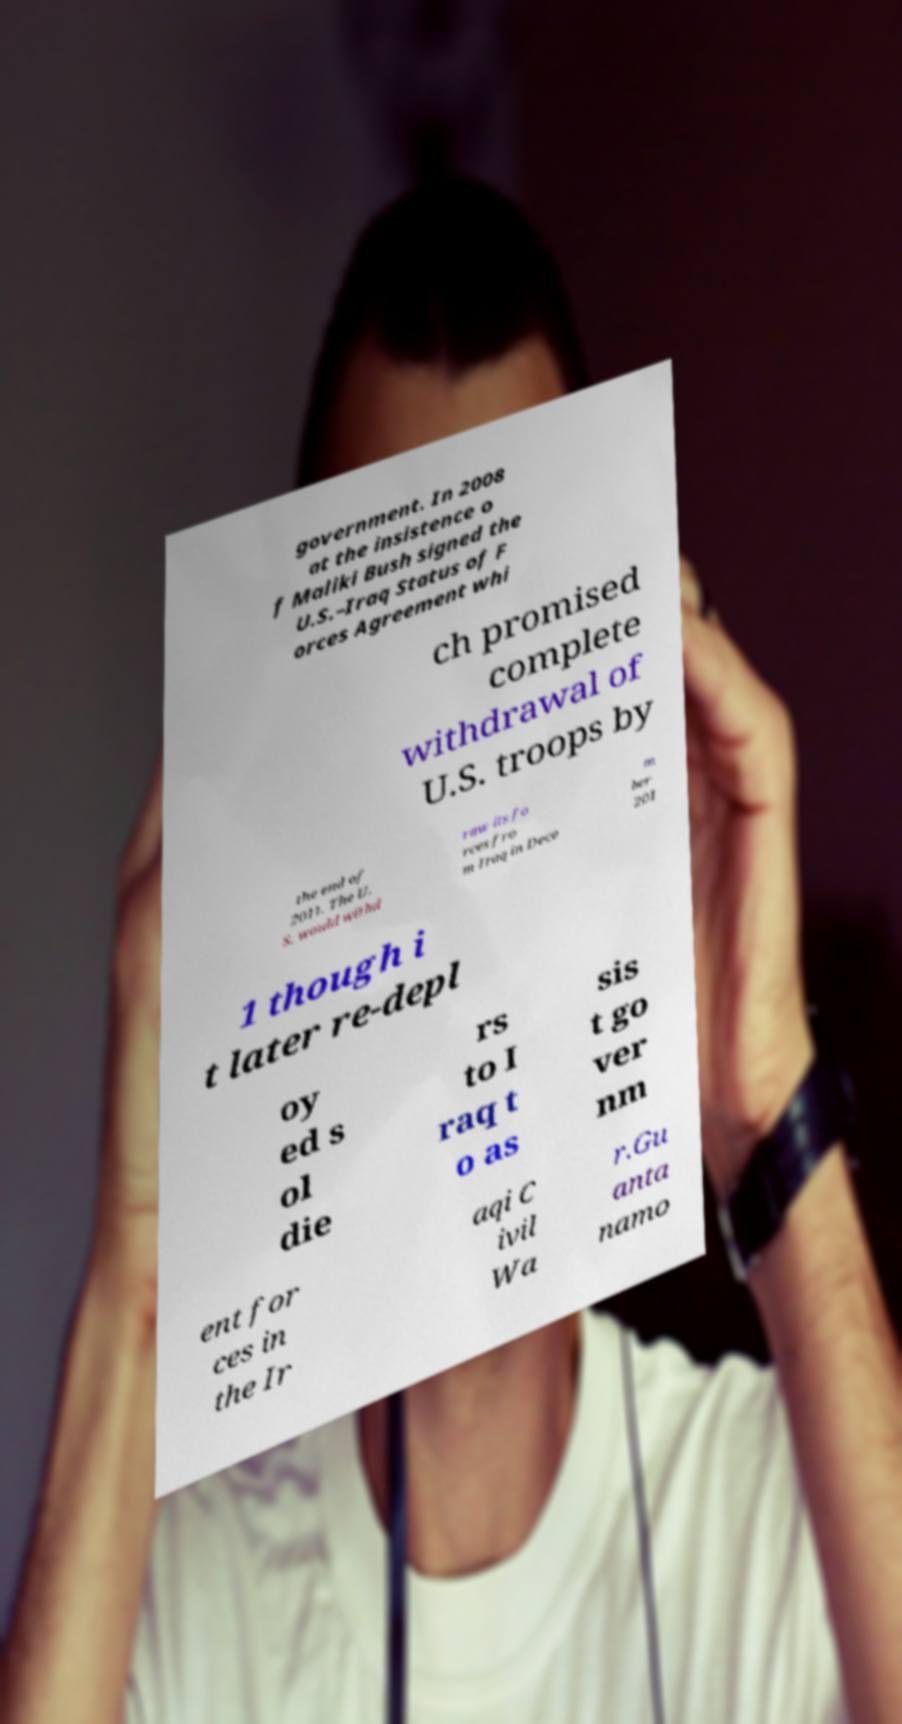Can you accurately transcribe the text from the provided image for me? government. In 2008 at the insistence o f Maliki Bush signed the U.S.–Iraq Status of F orces Agreement whi ch promised complete withdrawal of U.S. troops by the end of 2011. The U. S. would withd raw its fo rces fro m Iraq in Dece m ber 201 1 though i t later re-depl oy ed s ol die rs to I raq t o as sis t go ver nm ent for ces in the Ir aqi C ivil Wa r.Gu anta namo 